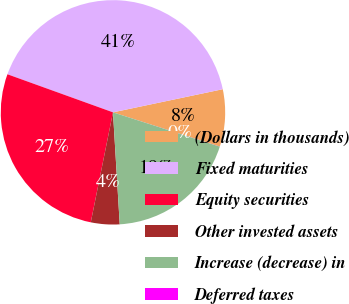Convert chart to OTSL. <chart><loc_0><loc_0><loc_500><loc_500><pie_chart><fcel>(Dollars in thousands)<fcel>Fixed maturities<fcel>Equity securities<fcel>Other invested assets<fcel>Increase (decrease) in<fcel>Deferred taxes<nl><fcel>8.24%<fcel>41.19%<fcel>27.34%<fcel>4.13%<fcel>19.1%<fcel>0.01%<nl></chart> 